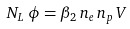Convert formula to latex. <formula><loc_0><loc_0><loc_500><loc_500>N _ { L } \, \phi = \beta _ { 2 } \, n _ { e } \, n _ { p } \, V</formula> 